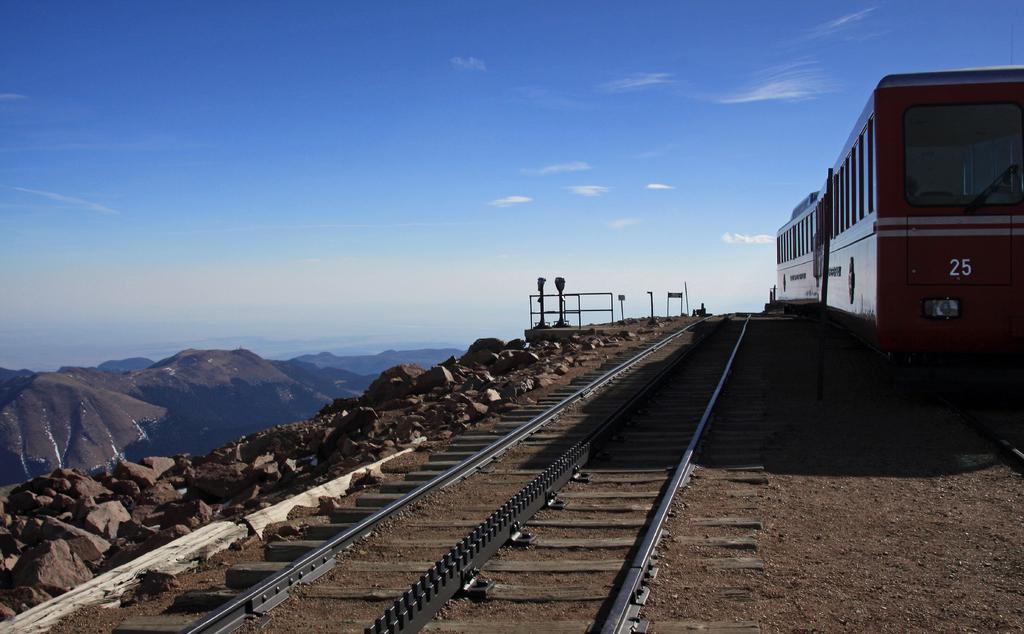What is the main subject of the image? The main subject of the image is a train. Where is the train located in the image? The train is on railway tracks in the image. What can be seen on the left side of the image? There are stones and hills visible on the left side of the image. What is visible in the sky at the top of the image? There are clouds in the sky at the top of the image. What type of beef can be seen hanging from the train in the image? There is no beef present in the image; it features a train on railway tracks with stones, hills, and clouds visible. What appliance is being used to create the sleet in the image? There is no sleet or appliance present in the image. 